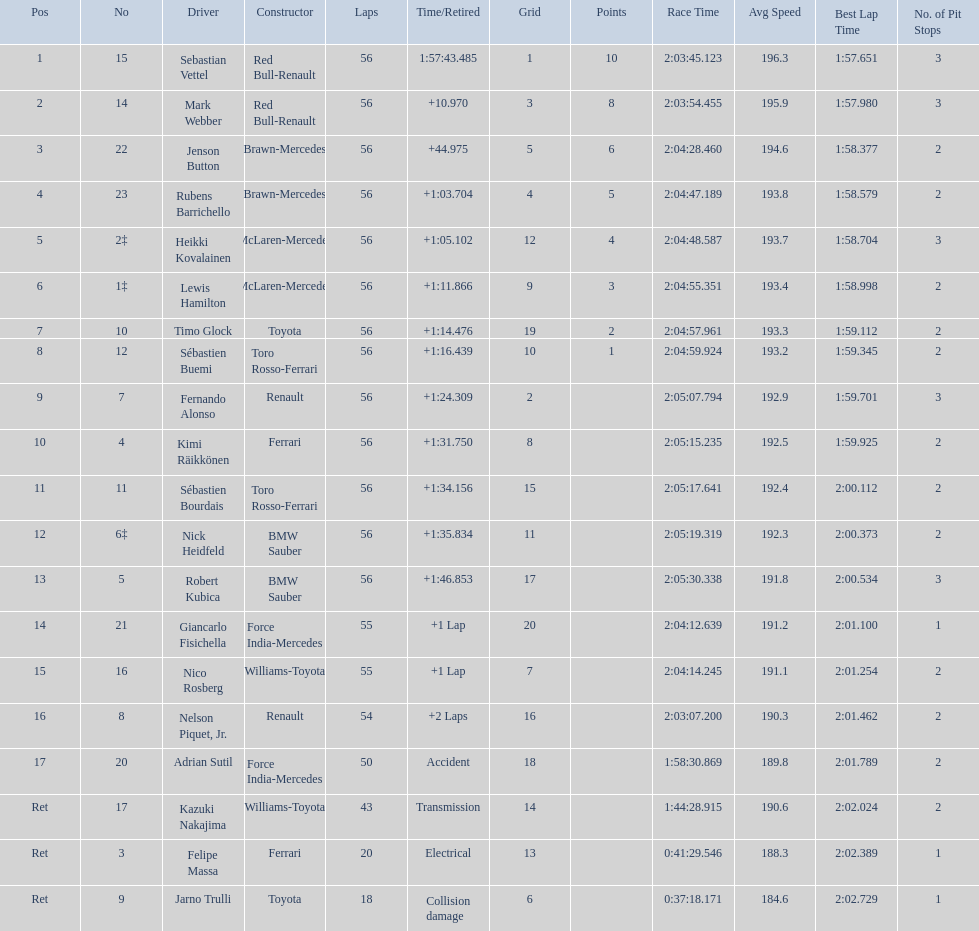Why did the  toyota retire Collision damage. What was the drivers name? Jarno Trulli. 